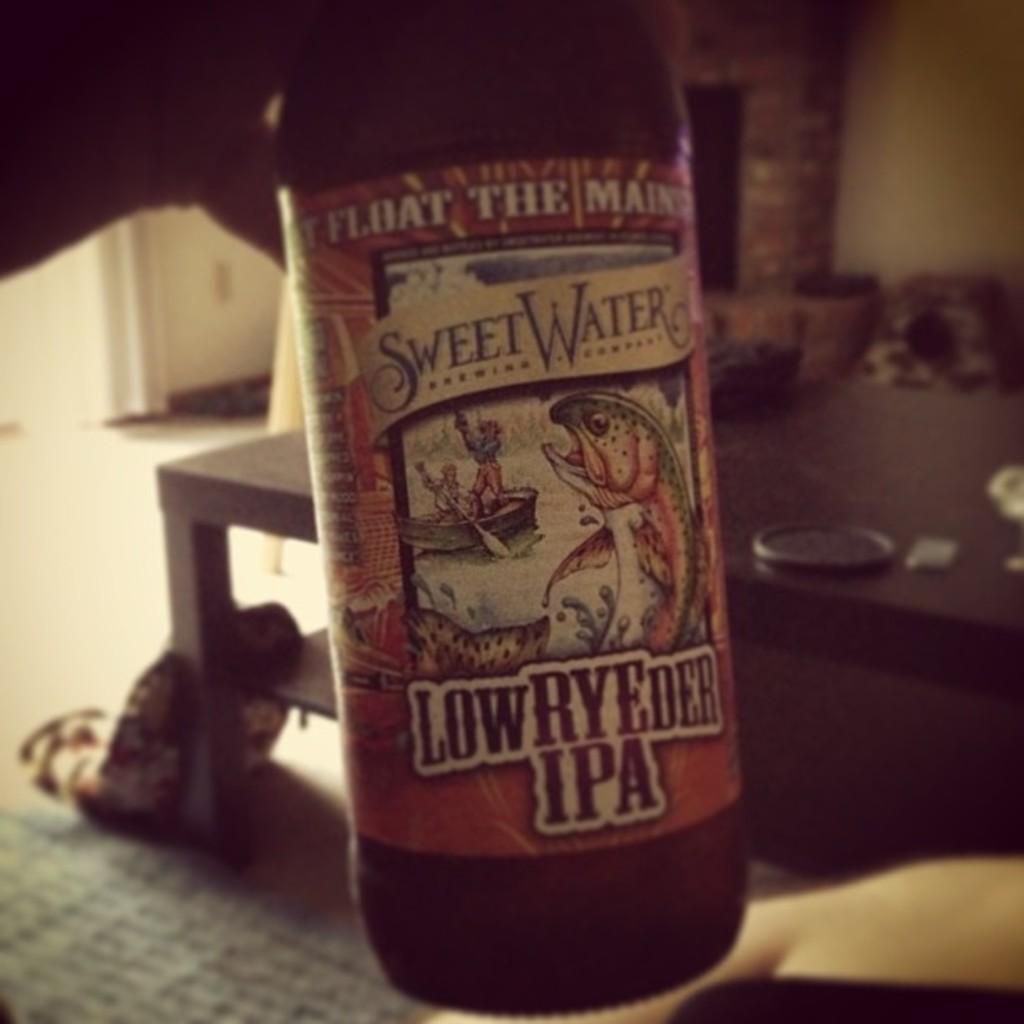<image>
Render a clear and concise summary of the photo. A person holding a bottle of Sweet Water LowRyder IPA. 